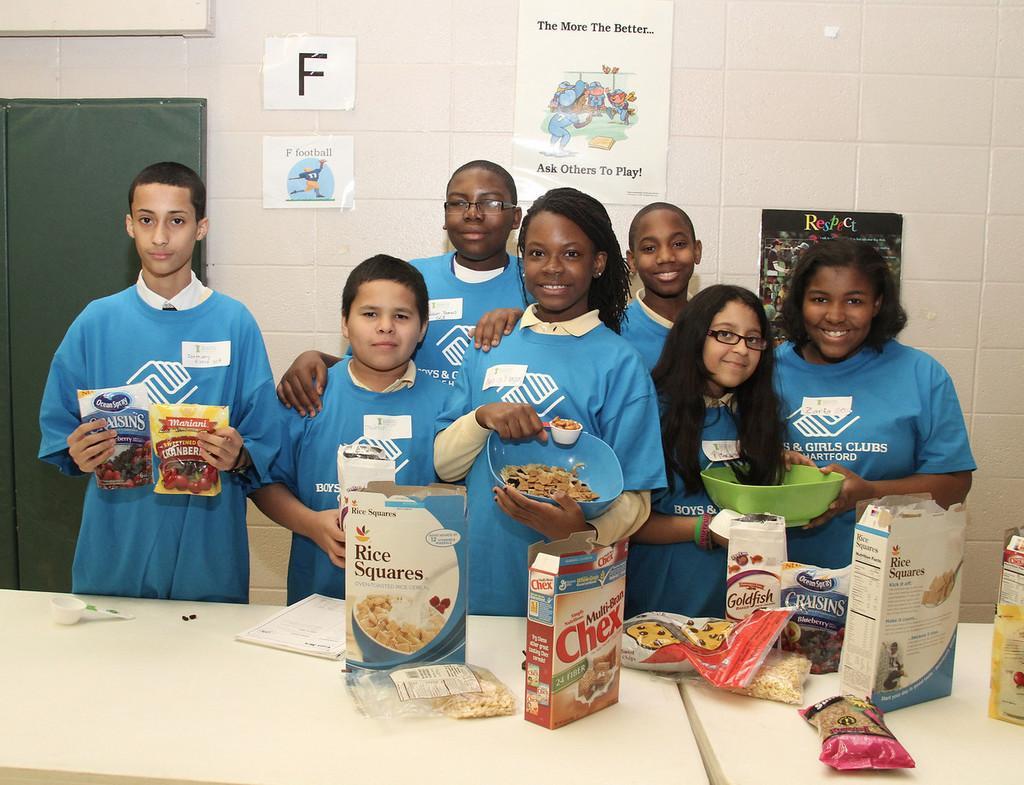Please provide a concise description of this image. In the center of the image we can see a few people are standing and they are smiling, which we can see on their faces. And they are holding some objects. In front of them, there is a table. On the table, we can see food products, packets, one book and a few other objects. In the background there is a wall, door, posters etc. 